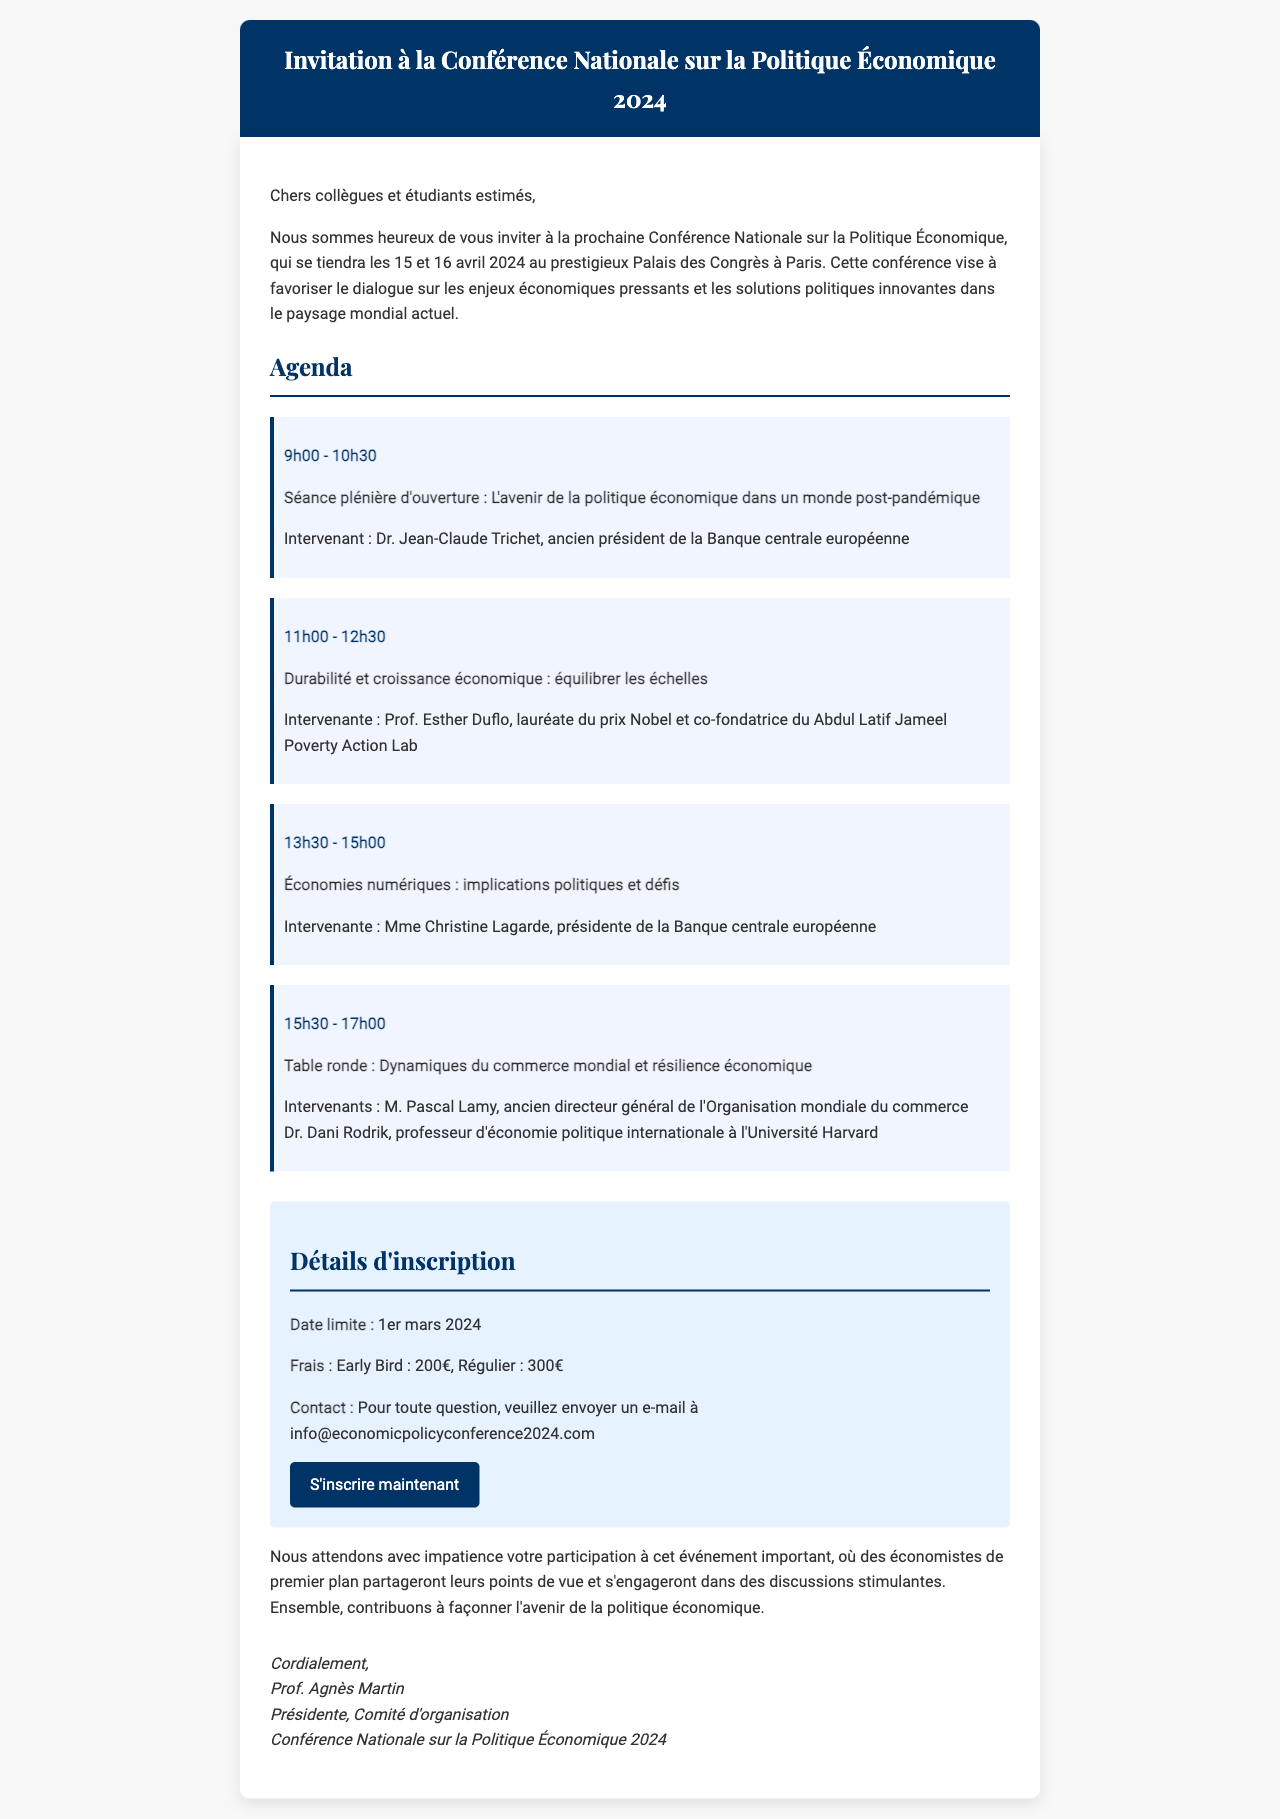Quel est le lieu de la conférence ? Le lieu de la conférence est précisé dans le document comme étant le Palais des Congrès à Paris.
Answer: Palais des Congrès à Paris Quelles sont les dates de la conférence ? Les dates de la conférence sont mentionnées dans le document et sont le 15 et 16 avril 2024.
Answer: 15 et 16 avril 2024 Qui est l'intervenant de la séance plénière d'ouverture ? L'intervenant de la séance plénière d'ouverture, selon le document, est Dr. Jean-Claude Trichet.
Answer: Dr. Jean-Claude Trichet Quel est le prix des frais d'inscription Early Bird ? Le document indique que les frais d'inscription Early Bird sont de 200€.
Answer: 200€ Quelle est la date limite d'inscription ? La date limite pour s'inscrire est spécifiée dans le document. Elle est 1er mars 2024.
Answer: 1er mars 2024 Qui préside le comité d'organisation ? La présidente du comité d'organisation est mentionnée dans la signature du document, à savoir Prof. Agnès Martin.
Answer: Prof. Agnès Martin Combien de sessions sont prévues dans l'agenda ? Le document présente quatre sessions différentes dans l'agenda de la conférence.
Answer: Quatre sessions Quel type de sujet sera abordé lors de la conférence ? Les sujets abordés incluent des enjeux économiques pressants et des solutions politiques innovantes, comme l'indique le début du document.
Answer: Enjeux économiques pressants et solutions politiques innovantes 